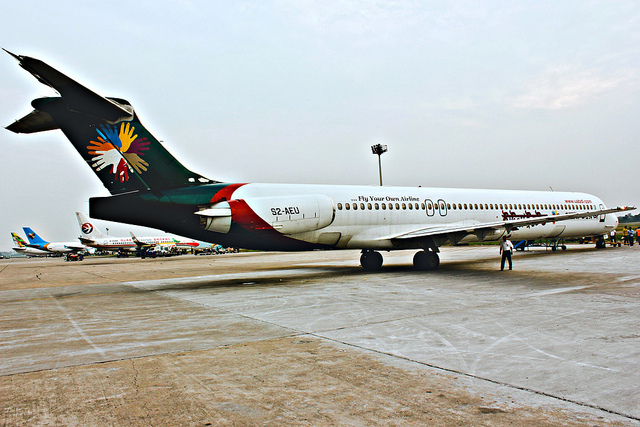Identify the text displayed in this image. S2 AEU Fly Your Own Airline 